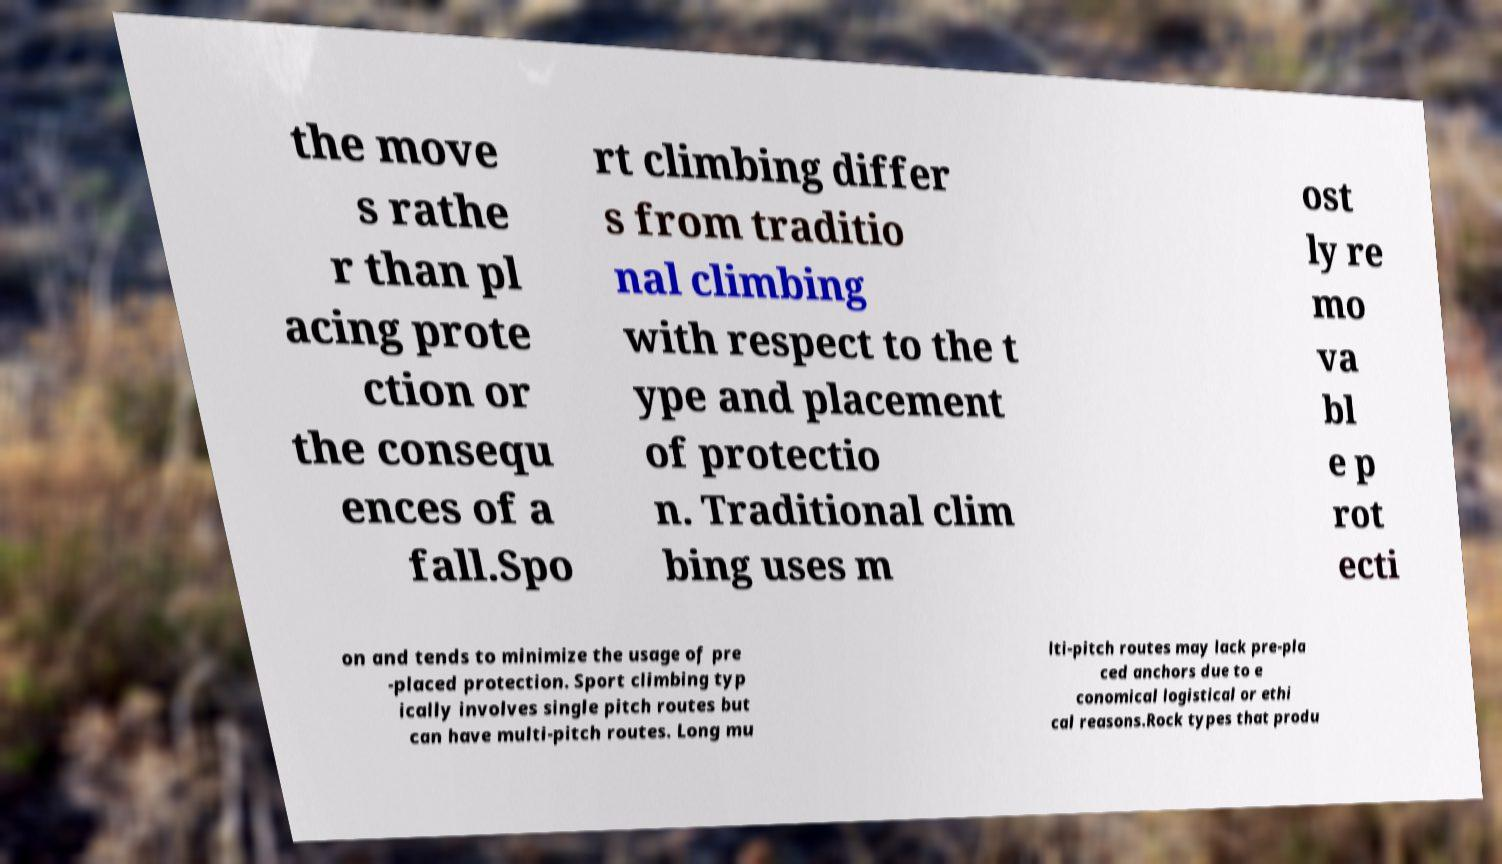Can you read and provide the text displayed in the image?This photo seems to have some interesting text. Can you extract and type it out for me? the move s rathe r than pl acing prote ction or the consequ ences of a fall.Spo rt climbing differ s from traditio nal climbing with respect to the t ype and placement of protectio n. Traditional clim bing uses m ost ly re mo va bl e p rot ecti on and tends to minimize the usage of pre -placed protection. Sport climbing typ ically involves single pitch routes but can have multi-pitch routes. Long mu lti-pitch routes may lack pre-pla ced anchors due to e conomical logistical or ethi cal reasons.Rock types that produ 